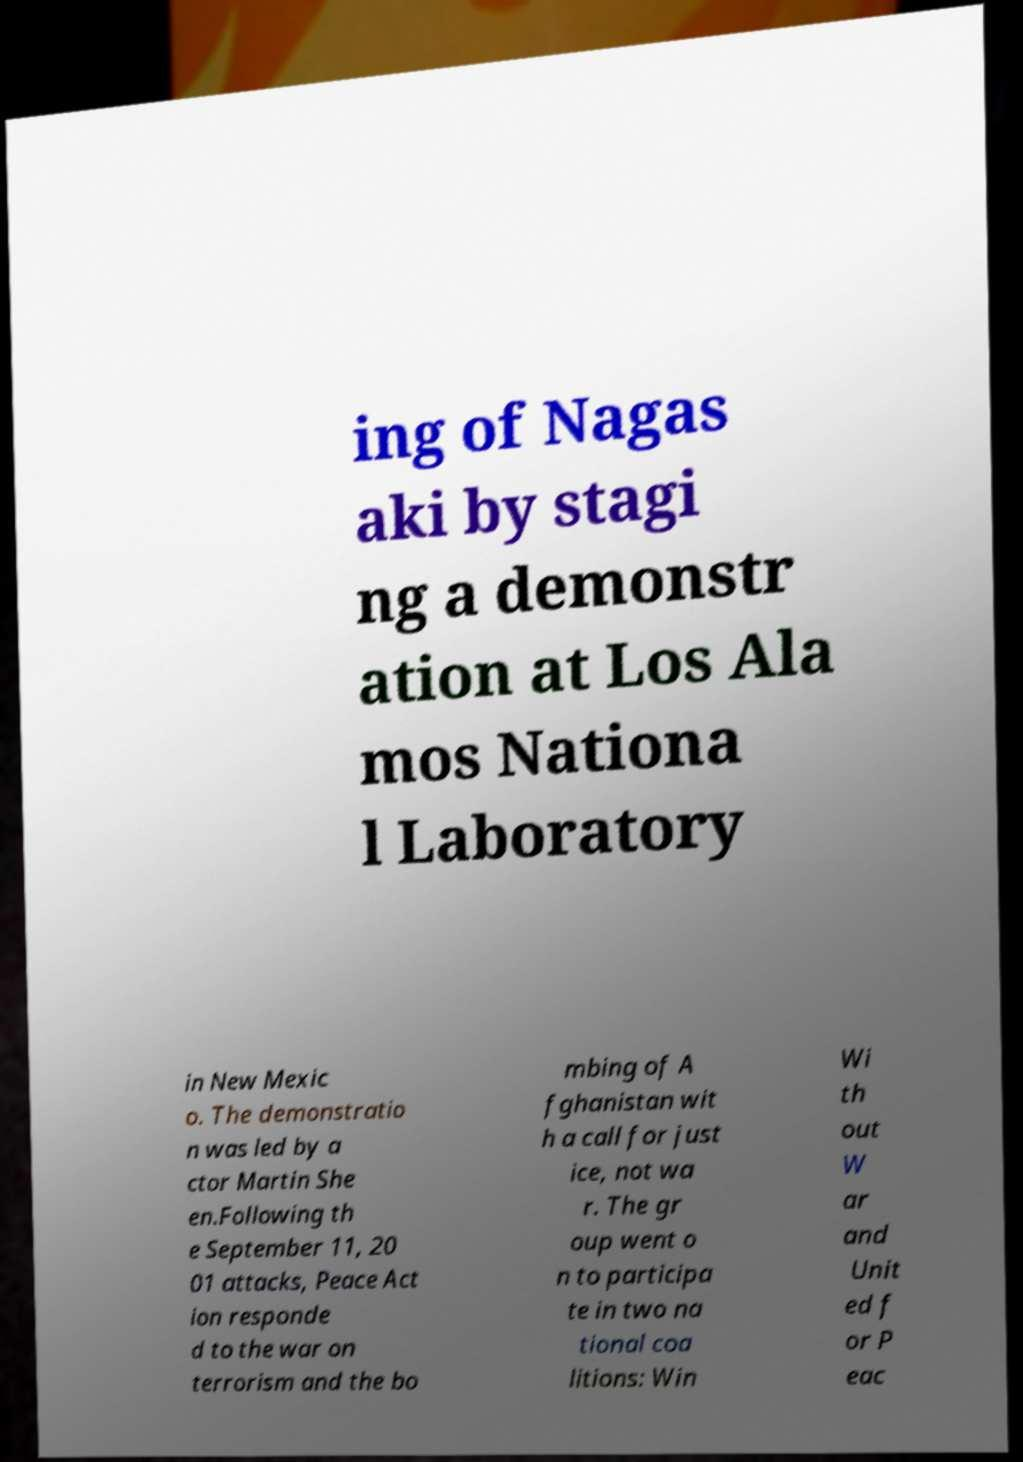Could you extract and type out the text from this image? ing of Nagas aki by stagi ng a demonstr ation at Los Ala mos Nationa l Laboratory in New Mexic o. The demonstratio n was led by a ctor Martin She en.Following th e September 11, 20 01 attacks, Peace Act ion responde d to the war on terrorism and the bo mbing of A fghanistan wit h a call for just ice, not wa r. The gr oup went o n to participa te in two na tional coa litions: Win Wi th out W ar and Unit ed f or P eac 